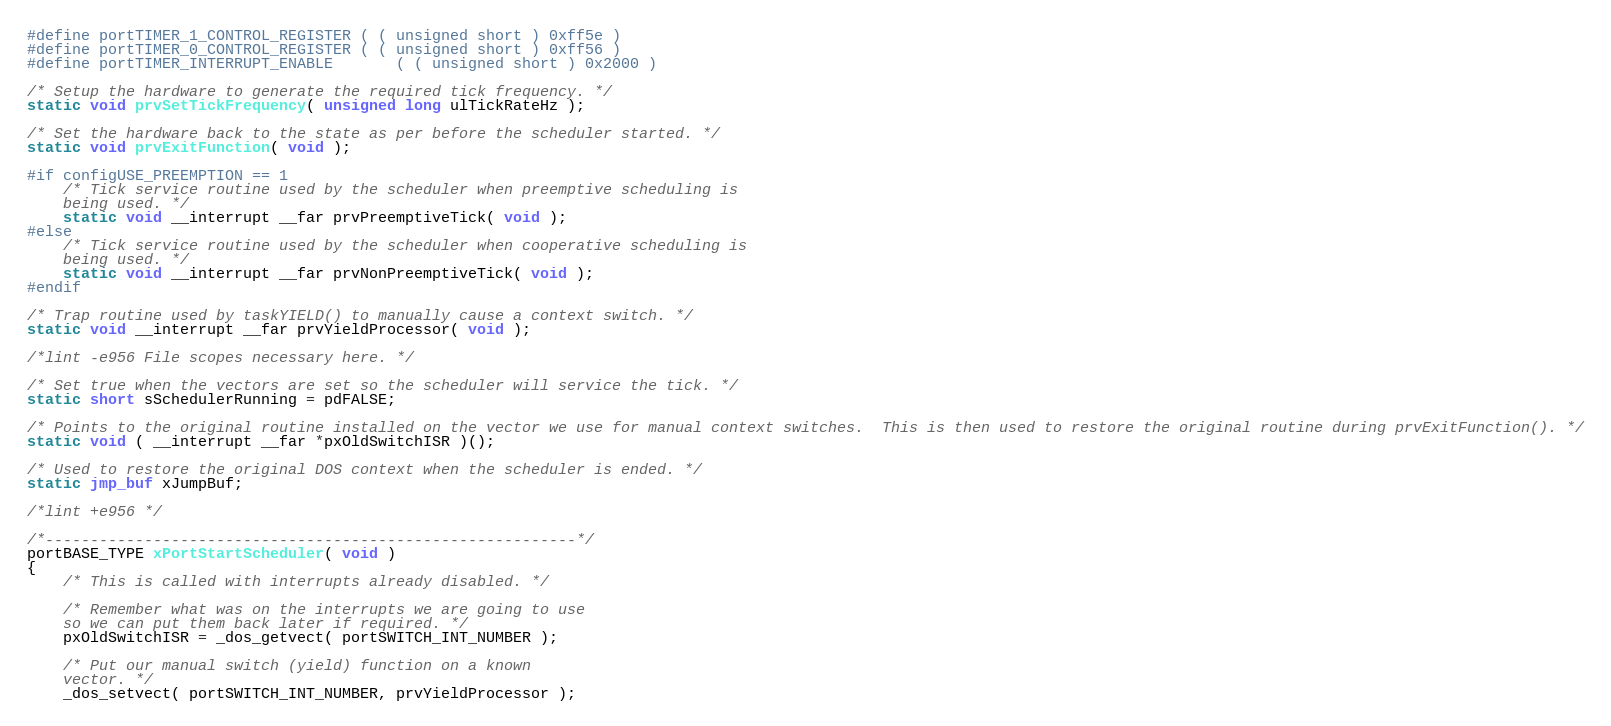Convert code to text. <code><loc_0><loc_0><loc_500><loc_500><_C_>#define portTIMER_1_CONTROL_REGISTER	( ( unsigned short ) 0xff5e )
#define portTIMER_0_CONTROL_REGISTER	( ( unsigned short ) 0xff56 )
#define portTIMER_INTERRUPT_ENABLE		( ( unsigned short ) 0x2000 )

/* Setup the hardware to generate the required tick frequency. */
static void prvSetTickFrequency( unsigned long ulTickRateHz );

/* Set the hardware back to the state as per before the scheduler started. */
static void prvExitFunction( void );

#if configUSE_PREEMPTION == 1
	/* Tick service routine used by the scheduler when preemptive scheduling is
	being used. */
	static void __interrupt __far prvPreemptiveTick( void );
#else
	/* Tick service routine used by the scheduler when cooperative scheduling is 
	being used. */
	static void __interrupt __far prvNonPreemptiveTick( void );
#endif

/* Trap routine used by taskYIELD() to manually cause a context switch. */
static void __interrupt __far prvYieldProcessor( void );

/*lint -e956 File scopes necessary here. */

/* Set true when the vectors are set so the scheduler will service the tick. */
static short sSchedulerRunning = pdFALSE;

/* Points to the original routine installed on the vector we use for manual context switches.  This is then used to restore the original routine during prvExitFunction(). */
static void ( __interrupt __far *pxOldSwitchISR )();

/* Used to restore the original DOS context when the scheduler is ended. */
static jmp_buf xJumpBuf;

/*lint +e956 */

/*-----------------------------------------------------------*/
portBASE_TYPE xPortStartScheduler( void )
{
	/* This is called with interrupts already disabled. */

	/* Remember what was on the interrupts we are going to use
	so we can put them back later if required. */
	pxOldSwitchISR = _dos_getvect( portSWITCH_INT_NUMBER );

	/* Put our manual switch (yield) function on a known
	vector. */
	_dos_setvect( portSWITCH_INT_NUMBER, prvYieldProcessor );
</code> 